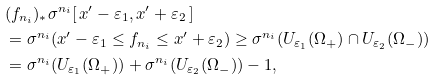Convert formula to latex. <formula><loc_0><loc_0><loc_500><loc_500>& ( f _ { n _ { i } } ) _ { * } \sigma ^ { n _ { i } } [ \, x ^ { \prime } - \varepsilon _ { 1 } , x ^ { \prime } + \varepsilon _ { 2 } \, ] \\ & = \sigma ^ { n _ { i } } ( x ^ { \prime } - \varepsilon _ { 1 } \leq f _ { n _ { i } } \leq x ^ { \prime } + \varepsilon _ { 2 } ) \geq \sigma ^ { n _ { i } } ( U _ { \varepsilon _ { 1 } } ( \Omega _ { + } ) \cap U _ { \varepsilon _ { 2 } } ( \Omega _ { - } ) ) \\ & = \sigma ^ { n _ { i } } ( U _ { \varepsilon _ { 1 } } ( \Omega _ { + } ) ) + \sigma ^ { n _ { i } } ( U _ { \varepsilon _ { 2 } } ( \Omega _ { - } ) ) - 1 ,</formula> 